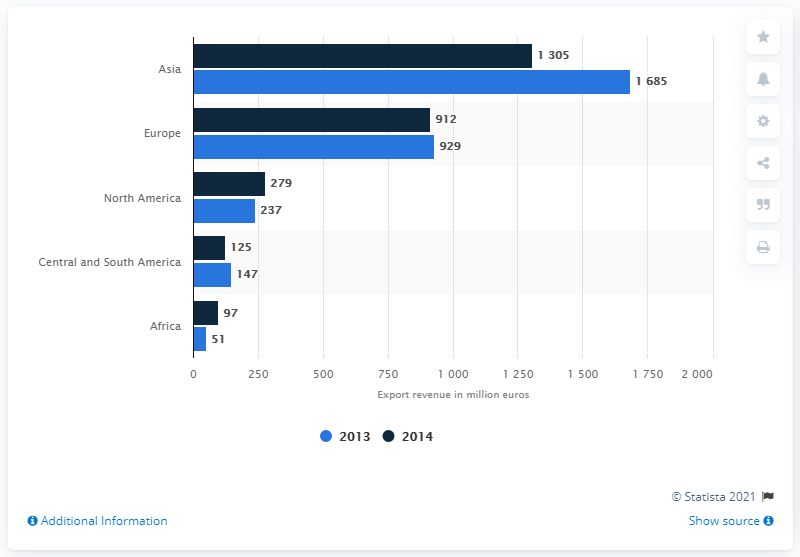Give some essential details in this illustration. In 2013, the revenue generated by Germany's textile machinery industry was 1,685 million euros. In 2013 and 2014, the average revenue generated by Asia from the textile industry was estimated to be 1495 million euros. The country with the largest textile machinery industry is Asia. 